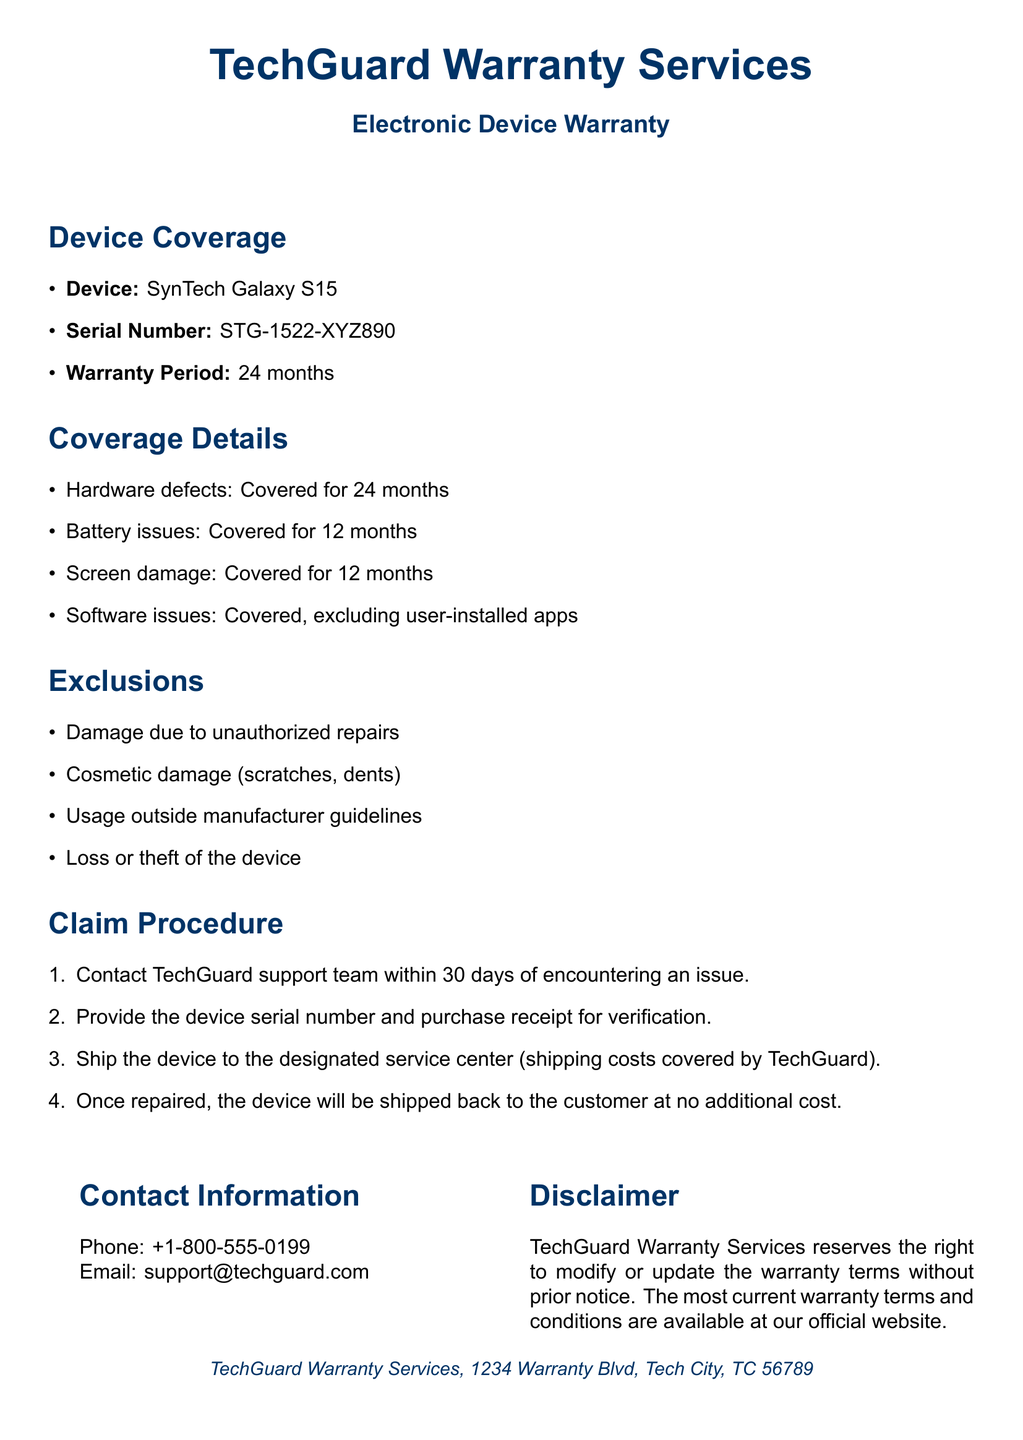what is the warranty period for the device? The warranty period for the SynTech Galaxy S15 is specified as 24 months in the document.
Answer: 24 months what issues are covered for 12 months? The coverage details mention that battery issues and screen damage are covered for 12 months.
Answer: Battery issues, Screen damage who should be contacted for the claim procedure? The document instructs to contact the TechGuard support team for the claim procedure.
Answer: TechGuard support team what is the serial number of the device? The document lists the serial number of the SynTech Galaxy S15 as STG-1522-XYZ890.
Answer: STG-1522-XYZ890 what is excluded from the warranty coverage? The document specifies damage due to unauthorized repairs as an exclusion from the warranty coverage.
Answer: Damage due to unauthorized repairs how long do you have to contact support after encountering an issue? The claim procedure states that the contact to support must be made within 30 days of encountering an issue.
Answer: 30 days what must be provided for verification when claiming a warranty? The document mentions that the device serial number and purchase receipt must be provided for verification in the claim procedure.
Answer: Device serial number and purchase receipt who is responsible for shipping costs when sending the device for repair? The document states that shipping costs are covered by TechGuard when sending the device to the service center.
Answer: TechGuard what does TechGuard reserve the right to do in regard to the warranty terms? The disclaimer section mentions that TechGuard reserves the right to modify or update the warranty terms without prior notice.
Answer: Modify or update the warranty terms 